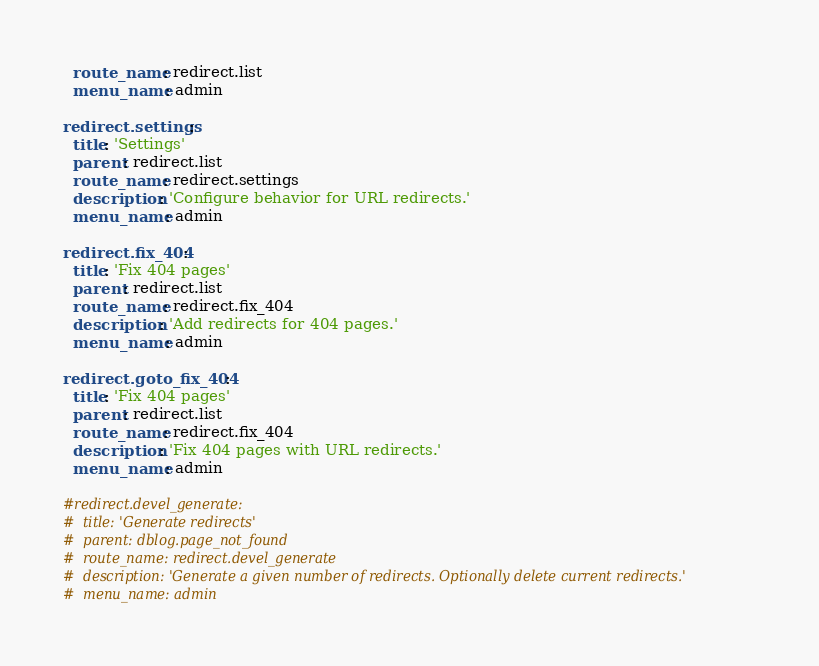Convert code to text. <code><loc_0><loc_0><loc_500><loc_500><_YAML_>  route_name: redirect.list
  menu_name: admin

redirect.settings:
  title: 'Settings'
  parent: redirect.list
  route_name: redirect.settings
  description: 'Configure behavior for URL redirects.'
  menu_name: admin

redirect.fix_404:
  title: 'Fix 404 pages'
  parent: redirect.list
  route_name: redirect.fix_404
  description: 'Add redirects for 404 pages.'
  menu_name: admin

redirect.goto_fix_404:
  title: 'Fix 404 pages'
  parent: redirect.list
  route_name: redirect.fix_404
  description: 'Fix 404 pages with URL redirects.'
  menu_name: admin

#redirect.devel_generate:
#  title: 'Generate redirects'
#  parent: dblog.page_not_found
#  route_name: redirect.devel_generate
#  description: 'Generate a given number of redirects. Optionally delete current redirects.'
#  menu_name: admin
</code> 